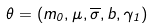Convert formula to latex. <formula><loc_0><loc_0><loc_500><loc_500>\theta = ( m _ { 0 } , \mu , \overline { \sigma } , b , \gamma _ { 1 } )</formula> 